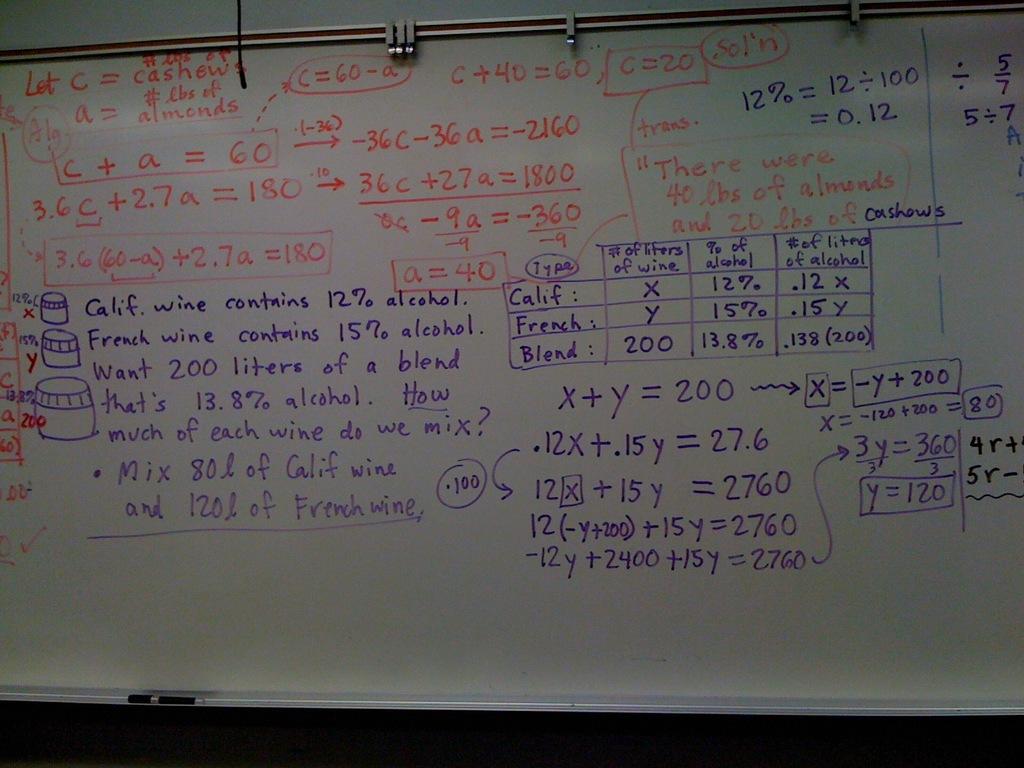How much alcohol does calif. wine contain?
Your response must be concise. 12%. 